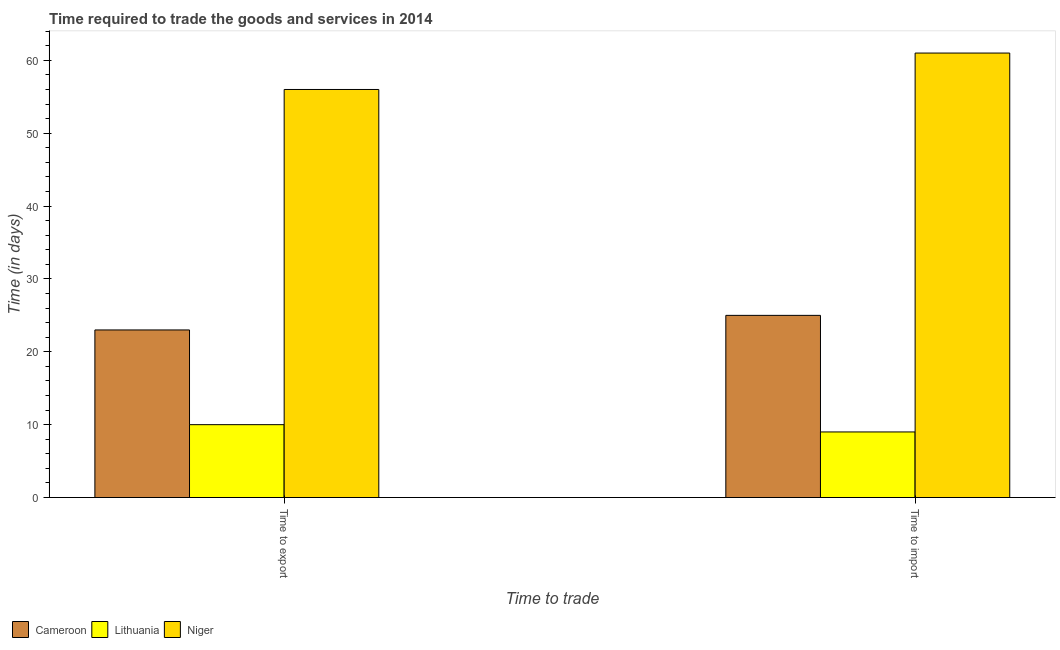Are the number of bars on each tick of the X-axis equal?
Make the answer very short. Yes. What is the label of the 1st group of bars from the left?
Keep it short and to the point. Time to export. What is the time to export in Lithuania?
Provide a short and direct response. 10. Across all countries, what is the maximum time to import?
Keep it short and to the point. 61. Across all countries, what is the minimum time to export?
Your answer should be very brief. 10. In which country was the time to export maximum?
Provide a short and direct response. Niger. In which country was the time to export minimum?
Provide a short and direct response. Lithuania. What is the total time to import in the graph?
Provide a short and direct response. 95. What is the difference between the time to export in Niger and that in Cameroon?
Your answer should be compact. 33. What is the difference between the time to import in Lithuania and the time to export in Niger?
Your answer should be very brief. -47. What is the average time to import per country?
Your response must be concise. 31.67. What is the difference between the time to import and time to export in Cameroon?
Ensure brevity in your answer.  2. What is the ratio of the time to export in Lithuania to that in Cameroon?
Your response must be concise. 0.43. Is the time to import in Lithuania less than that in Niger?
Keep it short and to the point. Yes. In how many countries, is the time to export greater than the average time to export taken over all countries?
Make the answer very short. 1. What does the 2nd bar from the left in Time to export represents?
Provide a succinct answer. Lithuania. What does the 2nd bar from the right in Time to export represents?
Your response must be concise. Lithuania. What is the difference between two consecutive major ticks on the Y-axis?
Your answer should be very brief. 10. Does the graph contain any zero values?
Offer a very short reply. No. How many legend labels are there?
Offer a terse response. 3. What is the title of the graph?
Give a very brief answer. Time required to trade the goods and services in 2014. Does "Trinidad and Tobago" appear as one of the legend labels in the graph?
Provide a succinct answer. No. What is the label or title of the X-axis?
Provide a short and direct response. Time to trade. What is the label or title of the Y-axis?
Offer a very short reply. Time (in days). What is the Time (in days) of Cameroon in Time to export?
Your response must be concise. 23. What is the Time (in days) in Lithuania in Time to export?
Ensure brevity in your answer.  10. What is the Time (in days) in Niger in Time to export?
Offer a very short reply. 56. What is the Time (in days) of Cameroon in Time to import?
Make the answer very short. 25. What is the Time (in days) of Lithuania in Time to import?
Make the answer very short. 9. What is the Time (in days) of Niger in Time to import?
Your response must be concise. 61. Across all Time to trade, what is the maximum Time (in days) in Lithuania?
Keep it short and to the point. 10. Across all Time to trade, what is the maximum Time (in days) in Niger?
Your answer should be compact. 61. What is the total Time (in days) in Lithuania in the graph?
Keep it short and to the point. 19. What is the total Time (in days) in Niger in the graph?
Your answer should be compact. 117. What is the difference between the Time (in days) of Lithuania in Time to export and that in Time to import?
Offer a terse response. 1. What is the difference between the Time (in days) of Niger in Time to export and that in Time to import?
Make the answer very short. -5. What is the difference between the Time (in days) of Cameroon in Time to export and the Time (in days) of Niger in Time to import?
Offer a terse response. -38. What is the difference between the Time (in days) in Lithuania in Time to export and the Time (in days) in Niger in Time to import?
Ensure brevity in your answer.  -51. What is the average Time (in days) in Niger per Time to trade?
Ensure brevity in your answer.  58.5. What is the difference between the Time (in days) in Cameroon and Time (in days) in Niger in Time to export?
Your answer should be very brief. -33. What is the difference between the Time (in days) of Lithuania and Time (in days) of Niger in Time to export?
Offer a terse response. -46. What is the difference between the Time (in days) in Cameroon and Time (in days) in Niger in Time to import?
Give a very brief answer. -36. What is the difference between the Time (in days) of Lithuania and Time (in days) of Niger in Time to import?
Offer a terse response. -52. What is the ratio of the Time (in days) in Cameroon in Time to export to that in Time to import?
Keep it short and to the point. 0.92. What is the ratio of the Time (in days) of Lithuania in Time to export to that in Time to import?
Ensure brevity in your answer.  1.11. What is the ratio of the Time (in days) in Niger in Time to export to that in Time to import?
Make the answer very short. 0.92. What is the difference between the highest and the lowest Time (in days) of Lithuania?
Give a very brief answer. 1. 